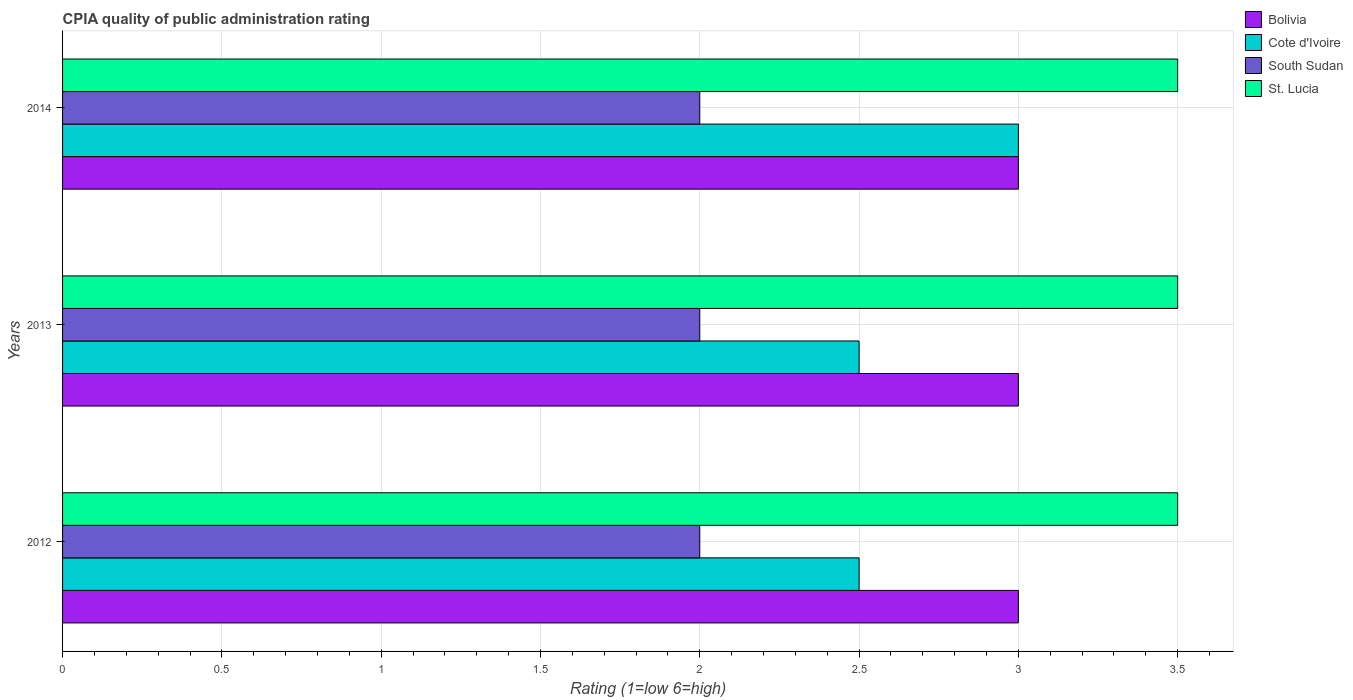Are the number of bars on each tick of the Y-axis equal?
Offer a very short reply. Yes. How many bars are there on the 1st tick from the top?
Provide a short and direct response. 4. How many bars are there on the 1st tick from the bottom?
Offer a very short reply. 4. What is the label of the 2nd group of bars from the top?
Keep it short and to the point. 2013. In how many cases, is the number of bars for a given year not equal to the number of legend labels?
Give a very brief answer. 0. What is the CPIA rating in South Sudan in 2014?
Give a very brief answer. 2. In which year was the CPIA rating in Cote d'Ivoire maximum?
Offer a very short reply. 2014. In which year was the CPIA rating in Bolivia minimum?
Your answer should be compact. 2012. What is the total CPIA rating in Cote d'Ivoire in the graph?
Offer a very short reply. 8. In the year 2013, what is the difference between the CPIA rating in Cote d'Ivoire and CPIA rating in South Sudan?
Your answer should be compact. 0.5. What is the ratio of the CPIA rating in South Sudan in 2012 to that in 2014?
Ensure brevity in your answer.  1. Is the CPIA rating in Cote d'Ivoire in 2012 less than that in 2014?
Your answer should be very brief. Yes. Is the difference between the CPIA rating in Cote d'Ivoire in 2013 and 2014 greater than the difference between the CPIA rating in South Sudan in 2013 and 2014?
Ensure brevity in your answer.  No. What is the difference between the highest and the second highest CPIA rating in Cote d'Ivoire?
Ensure brevity in your answer.  0.5. What is the difference between the highest and the lowest CPIA rating in St. Lucia?
Ensure brevity in your answer.  0. In how many years, is the CPIA rating in Cote d'Ivoire greater than the average CPIA rating in Cote d'Ivoire taken over all years?
Your answer should be compact. 1. Is the sum of the CPIA rating in St. Lucia in 2012 and 2013 greater than the maximum CPIA rating in Cote d'Ivoire across all years?
Your answer should be compact. Yes. What does the 3rd bar from the top in 2014 represents?
Provide a short and direct response. Cote d'Ivoire. What does the 4th bar from the bottom in 2013 represents?
Make the answer very short. St. Lucia. Is it the case that in every year, the sum of the CPIA rating in St. Lucia and CPIA rating in South Sudan is greater than the CPIA rating in Cote d'Ivoire?
Ensure brevity in your answer.  Yes. How many bars are there?
Keep it short and to the point. 12. What is the difference between two consecutive major ticks on the X-axis?
Make the answer very short. 0.5. Are the values on the major ticks of X-axis written in scientific E-notation?
Provide a succinct answer. No. Does the graph contain any zero values?
Offer a very short reply. No. How are the legend labels stacked?
Make the answer very short. Vertical. What is the title of the graph?
Make the answer very short. CPIA quality of public administration rating. What is the label or title of the X-axis?
Provide a short and direct response. Rating (1=low 6=high). What is the label or title of the Y-axis?
Provide a succinct answer. Years. What is the Rating (1=low 6=high) of Bolivia in 2012?
Your answer should be very brief. 3. What is the Rating (1=low 6=high) in Cote d'Ivoire in 2012?
Offer a very short reply. 2.5. What is the Rating (1=low 6=high) in St. Lucia in 2012?
Your answer should be very brief. 3.5. What is the Rating (1=low 6=high) of St. Lucia in 2013?
Ensure brevity in your answer.  3.5. What is the Rating (1=low 6=high) in Cote d'Ivoire in 2014?
Provide a succinct answer. 3. What is the Rating (1=low 6=high) of South Sudan in 2014?
Ensure brevity in your answer.  2. Across all years, what is the maximum Rating (1=low 6=high) in Bolivia?
Offer a very short reply. 3. Across all years, what is the maximum Rating (1=low 6=high) in St. Lucia?
Keep it short and to the point. 3.5. Across all years, what is the minimum Rating (1=low 6=high) in Bolivia?
Give a very brief answer. 3. Across all years, what is the minimum Rating (1=low 6=high) of Cote d'Ivoire?
Your answer should be very brief. 2.5. What is the total Rating (1=low 6=high) of South Sudan in the graph?
Ensure brevity in your answer.  6. What is the total Rating (1=low 6=high) in St. Lucia in the graph?
Keep it short and to the point. 10.5. What is the difference between the Rating (1=low 6=high) of St. Lucia in 2012 and that in 2013?
Give a very brief answer. 0. What is the difference between the Rating (1=low 6=high) of Cote d'Ivoire in 2012 and that in 2014?
Your answer should be very brief. -0.5. What is the difference between the Rating (1=low 6=high) in South Sudan in 2012 and that in 2014?
Your response must be concise. 0. What is the difference between the Rating (1=low 6=high) of St. Lucia in 2012 and that in 2014?
Provide a short and direct response. 0. What is the difference between the Rating (1=low 6=high) in Bolivia in 2013 and that in 2014?
Offer a terse response. 0. What is the difference between the Rating (1=low 6=high) of Cote d'Ivoire in 2013 and that in 2014?
Offer a terse response. -0.5. What is the difference between the Rating (1=low 6=high) of South Sudan in 2013 and that in 2014?
Provide a succinct answer. 0. What is the difference between the Rating (1=low 6=high) in St. Lucia in 2013 and that in 2014?
Make the answer very short. 0. What is the difference between the Rating (1=low 6=high) in Bolivia in 2012 and the Rating (1=low 6=high) in St. Lucia in 2013?
Provide a short and direct response. -0.5. What is the difference between the Rating (1=low 6=high) of South Sudan in 2012 and the Rating (1=low 6=high) of St. Lucia in 2013?
Provide a short and direct response. -1.5. What is the difference between the Rating (1=low 6=high) of Bolivia in 2012 and the Rating (1=low 6=high) of Cote d'Ivoire in 2014?
Your response must be concise. 0. What is the difference between the Rating (1=low 6=high) of Bolivia in 2012 and the Rating (1=low 6=high) of St. Lucia in 2014?
Offer a very short reply. -0.5. What is the difference between the Rating (1=low 6=high) of Cote d'Ivoire in 2012 and the Rating (1=low 6=high) of South Sudan in 2014?
Give a very brief answer. 0.5. What is the difference between the Rating (1=low 6=high) in Cote d'Ivoire in 2012 and the Rating (1=low 6=high) in St. Lucia in 2014?
Provide a succinct answer. -1. What is the difference between the Rating (1=low 6=high) of South Sudan in 2012 and the Rating (1=low 6=high) of St. Lucia in 2014?
Offer a terse response. -1.5. What is the difference between the Rating (1=low 6=high) in Bolivia in 2013 and the Rating (1=low 6=high) in Cote d'Ivoire in 2014?
Your answer should be compact. 0. What is the difference between the Rating (1=low 6=high) in Bolivia in 2013 and the Rating (1=low 6=high) in South Sudan in 2014?
Your response must be concise. 1. What is the average Rating (1=low 6=high) of Bolivia per year?
Provide a succinct answer. 3. What is the average Rating (1=low 6=high) in Cote d'Ivoire per year?
Your answer should be compact. 2.67. In the year 2012, what is the difference between the Rating (1=low 6=high) in Bolivia and Rating (1=low 6=high) in South Sudan?
Make the answer very short. 1. In the year 2013, what is the difference between the Rating (1=low 6=high) of Bolivia and Rating (1=low 6=high) of Cote d'Ivoire?
Make the answer very short. 0.5. In the year 2013, what is the difference between the Rating (1=low 6=high) in Bolivia and Rating (1=low 6=high) in South Sudan?
Give a very brief answer. 1. In the year 2013, what is the difference between the Rating (1=low 6=high) of Cote d'Ivoire and Rating (1=low 6=high) of St. Lucia?
Your response must be concise. -1. In the year 2013, what is the difference between the Rating (1=low 6=high) in South Sudan and Rating (1=low 6=high) in St. Lucia?
Offer a terse response. -1.5. In the year 2014, what is the difference between the Rating (1=low 6=high) in Bolivia and Rating (1=low 6=high) in South Sudan?
Give a very brief answer. 1. In the year 2014, what is the difference between the Rating (1=low 6=high) of Bolivia and Rating (1=low 6=high) of St. Lucia?
Give a very brief answer. -0.5. In the year 2014, what is the difference between the Rating (1=low 6=high) of Cote d'Ivoire and Rating (1=low 6=high) of St. Lucia?
Provide a short and direct response. -0.5. In the year 2014, what is the difference between the Rating (1=low 6=high) of South Sudan and Rating (1=low 6=high) of St. Lucia?
Keep it short and to the point. -1.5. What is the ratio of the Rating (1=low 6=high) in Bolivia in 2012 to that in 2014?
Make the answer very short. 1. What is the ratio of the Rating (1=low 6=high) of Cote d'Ivoire in 2012 to that in 2014?
Your response must be concise. 0.83. What is the ratio of the Rating (1=low 6=high) of Cote d'Ivoire in 2013 to that in 2014?
Your response must be concise. 0.83. What is the ratio of the Rating (1=low 6=high) of St. Lucia in 2013 to that in 2014?
Provide a succinct answer. 1. What is the difference between the highest and the second highest Rating (1=low 6=high) in Cote d'Ivoire?
Make the answer very short. 0.5. What is the difference between the highest and the lowest Rating (1=low 6=high) of Bolivia?
Provide a succinct answer. 0. What is the difference between the highest and the lowest Rating (1=low 6=high) of Cote d'Ivoire?
Provide a succinct answer. 0.5. What is the difference between the highest and the lowest Rating (1=low 6=high) in South Sudan?
Provide a short and direct response. 0. 